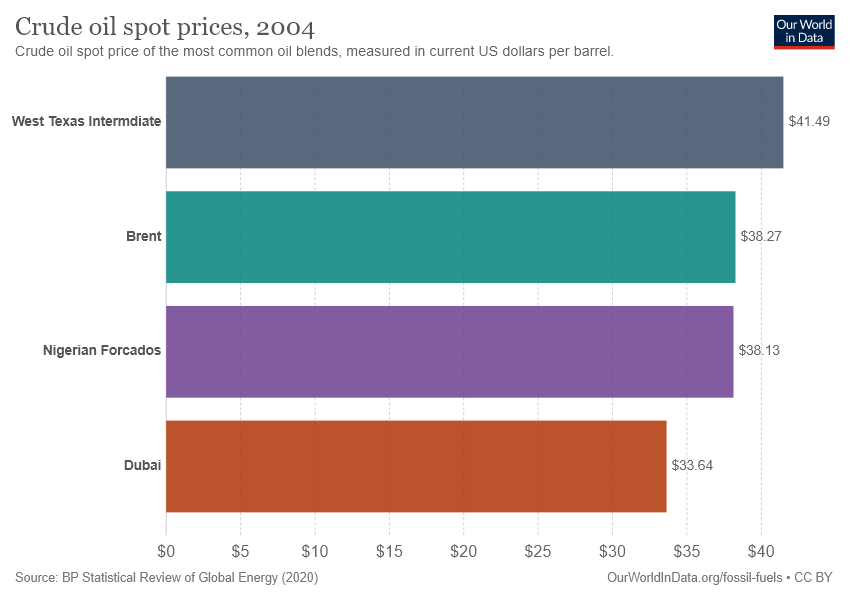Mention a couple of crucial points in this snapshot. The name that is represented by the second top bar is Brent. The average of the bottom three countries is 36.68. 